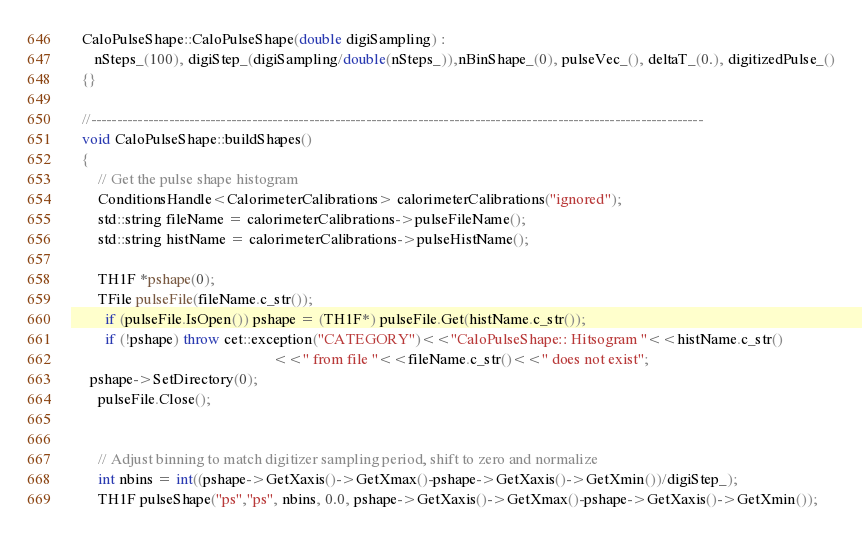Convert code to text. <code><loc_0><loc_0><loc_500><loc_500><_C++_>
   CaloPulseShape::CaloPulseShape(double digiSampling) :
      nSteps_(100), digiStep_(digiSampling/double(nSteps_)),nBinShape_(0), pulseVec_(), deltaT_(0.), digitizedPulse_()
   {}

   //----------------------------------------------------------------------------------------------------------------------
   void CaloPulseShape::buildShapes()
   {
       // Get the pulse shape histogram
       ConditionsHandle<CalorimeterCalibrations> calorimeterCalibrations("ignored");
       std::string fileName = calorimeterCalibrations->pulseFileName();
       std::string histName = calorimeterCalibrations->pulseHistName();

       TH1F *pshape(0);
       TFile pulseFile(fileName.c_str());
         if (pulseFile.IsOpen()) pshape = (TH1F*) pulseFile.Get(histName.c_str());
         if (!pshape) throw cet::exception("CATEGORY")<<"CaloPulseShape:: Hitsogram "<<histName.c_str()
                                                     <<" from file "<<fileName.c_str()<<" does not exist";
	 pshape->SetDirectory(0);
       pulseFile.Close();


       // Adjust binning to match digitizer sampling period, shift to zero and normalize
       int nbins = int((pshape->GetXaxis()->GetXmax()-pshape->GetXaxis()->GetXmin())/digiStep_);
       TH1F pulseShape("ps","ps", nbins, 0.0, pshape->GetXaxis()->GetXmax()-pshape->GetXaxis()->GetXmin());</code> 